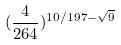<formula> <loc_0><loc_0><loc_500><loc_500>( \frac { 4 } { 2 6 4 } ) ^ { 1 0 / 1 9 7 - \sqrt { 9 } }</formula> 